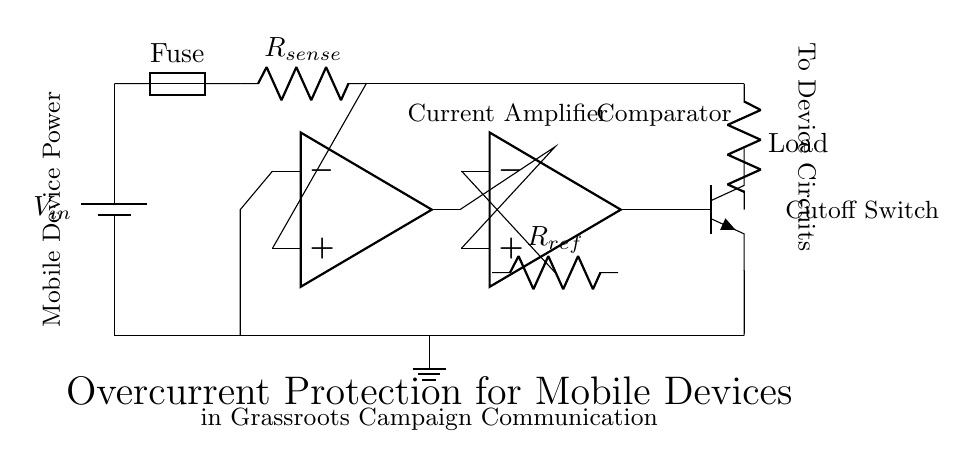What is the input voltage for this circuit? The input voltage is labeled as V in, which appears at the top of the schematic diagram connected to the battery.
Answer: V in What component is used for overcurrent protection? The fuse is specifically labeled in the circuit and is used to protect against overcurrent conditions by breaking the circuit.
Answer: Fuse What role does the current sensing resistor play? R sense is connected in series and is used to measure the current flowing through the circuit; it helps to detect overcurrent situations.
Answer: Current sensing What type of amplifier is used in this circuit? The current amplifier is shown in the schematic as an operational amplifier, which helps to amplify the current through the R sense resistor for further processing.
Answer: Operational amplifier How does the comparator contribute to overcurrent protection? The comparator takes input from the current amplifier and a reference resistor, helping to determine whether the current exceeds a set threshold, thus triggering a cutoff.
Answer: Threshold detection What type of transistor is utilized for switching? The circuit shows an NPN transistor that acts as a cutoff switch to disconnect the load when an overcurrent condition is detected by the comparator.
Answer: NPN What is the output that the circuit provides? The output from this circuit, which is connected to the load, indicates that it manages the delivery of power to mobile devices while ensuring safety through overcurrent protection measures.
Answer: To Device Circuits 